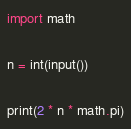Convert code to text. <code><loc_0><loc_0><loc_500><loc_500><_Python_>import math

n = int(input())

print(2 * n * math.pi)</code> 